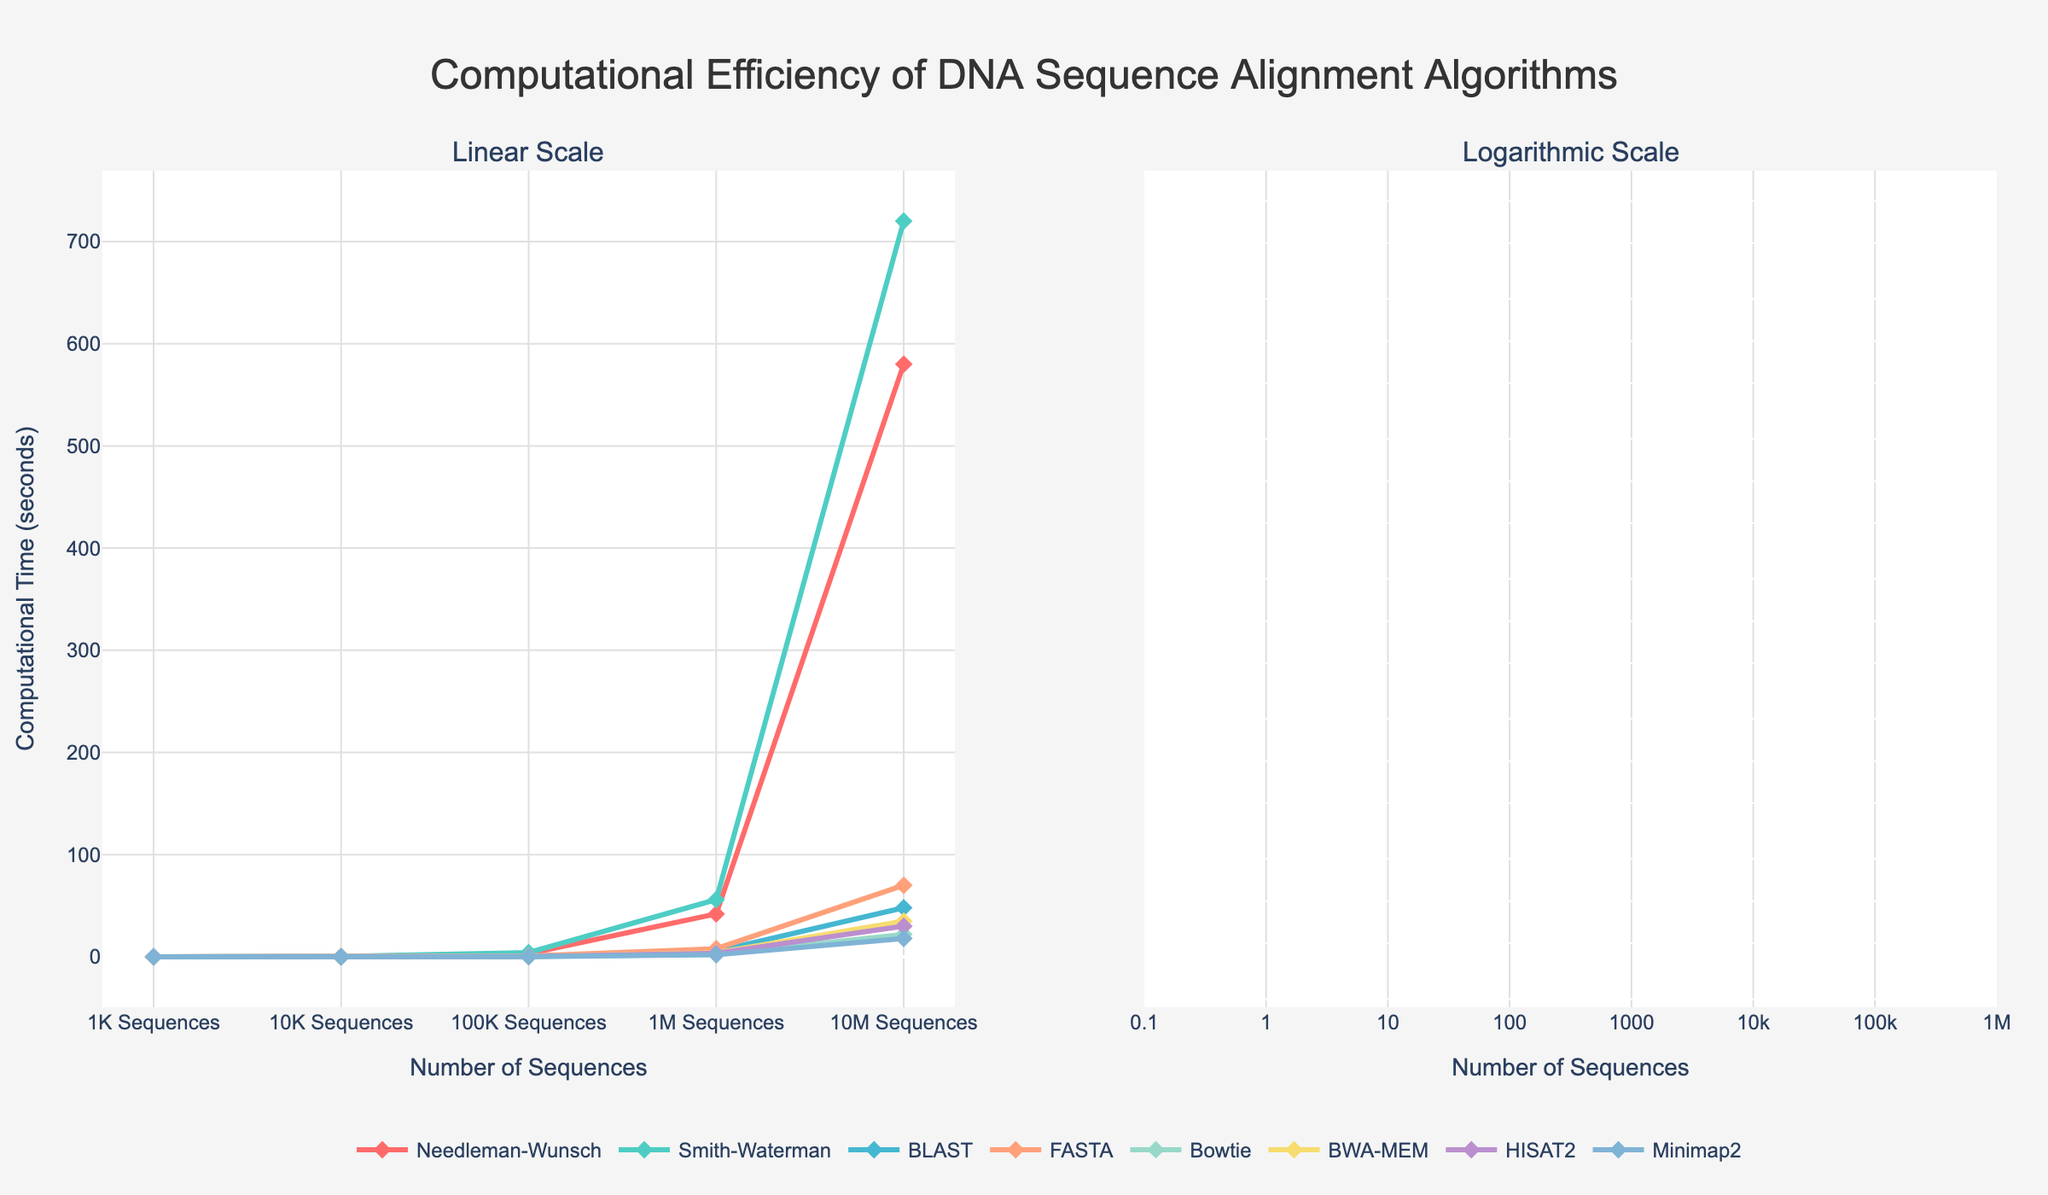What is the computational efficiency of the Needleman-Wunsch algorithm for 1K Sequences and 10M Sequences? Check the line representing the Needleman-Wunsch algorithm on the linear scale plot, which shows the computational time for 1K Sequences as 0.02 seconds and for 10M Sequences as 580 seconds.
Answer: For 1K Sequences: 0.02 seconds, For 10M Sequences: 580 seconds Which algorithm is the most computationally efficient for the largest dataset size of 10M Sequences? On the linear scale plot, identify the algorithm with the smallest Y value (computational time) at the 10M Sequences point. Minimap2 shows the lowest computational time of 18 seconds at this point.
Answer: Minimap2 Between Smith-Waterman and BLAST, which algorithm has a faster computational efficiency for 1M Sequences, and by how much? Check the Y values at the 1M Sequences point for both algorithms. Smith-Waterman has a computational time of 56 seconds, and BLAST has a computational time of 5.5 seconds. Subtract BLAST's computational time from Smith-Waterman's. 56 - 5.5 = 50.5 seconds.
Answer: BLAST, by 50.5 seconds Which algorithms have their computational times for 10M Sequences on the logarithmic scale plot that are very close visually? On the logarithmic scale plot, identify algorithms whose markers at the 10M Sequences point are closely spaced. BWA-MEM and HISAT2 have computational times of 35 and 30 seconds, respectively, which are close to each other.
Answer: BWA-MEM and HISAT2 What is the color of the line representing the performance of Bowtie, and how does its computational efficiency change as the number of sequences increases from 1K to 10M? Find the line representing Bowtie in the legend; it is light blue in color. As the number of sequences increases from 1K to 10M, Bowtie's computational efficiency changes from 0.005 seconds to 22 seconds.
Answer: Light blue, increases from 0.005 seconds to 22 seconds Comparing FASTA and Minimap2, which algorithm demonstrates a larger increase in computational time when moving from 1M Sequences to 10M Sequences? Calculate the difference in computational time for FASTA and Minimap2 algorithms between 1M Sequences and 10M Sequences points. FASTA: 70 - 8 = 62, Minimap2: 18 - 2 = 16. FASTA demonstrates a larger increase.
Answer: FASTA What are the sequence sizes displayed on the x-axis in both the linear and logarithmic scale plots? Examine the x-axis labels in both plots. They show: 1K Sequences, 10K Sequences, 100K Sequences, 1M Sequences, and 10M Sequences.
Answer: 1K, 10K, 100K, 1M, 10M Sequences Based on the plots, which algorithm shows the least increase in computational time when comparing 1K Sequences to 100K Sequences? Look at the lines for all algorithms and determine the one with the smallest difference in Y values between the 1K Sequences and 100K Sequences points. Bowtie increases from 0.005 seconds to 0.3 seconds, which is the smallest increase compared to other algorithms.
Answer: Bowtie 